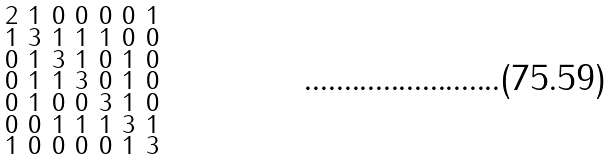<formula> <loc_0><loc_0><loc_500><loc_500>\begin{smallmatrix} 2 & 1 & 0 & 0 & 0 & 0 & 1 \\ 1 & 3 & 1 & 1 & 1 & 0 & 0 \\ 0 & 1 & 3 & 1 & 0 & 1 & 0 \\ 0 & 1 & 1 & 3 & 0 & 1 & 0 \\ 0 & 1 & 0 & 0 & 3 & 1 & 0 \\ 0 & 0 & 1 & 1 & 1 & 3 & 1 \\ 1 & 0 & 0 & 0 & 0 & 1 & 3 \end{smallmatrix}</formula> 